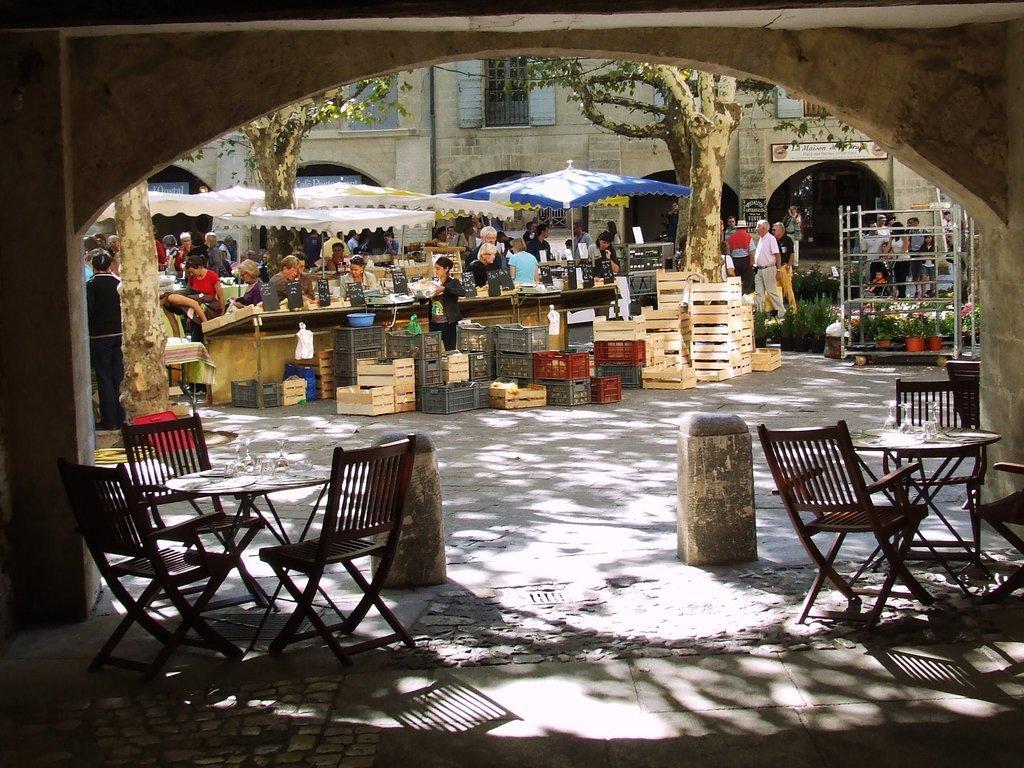In one or two sentences, can you explain what this image depicts? In the foreground of this image, there are chairs, tables on the ground. We can also see bollards and an arch at the top. In the background, there are baskets, few people standing, umbrellas, trees and also we can see the walls, windows and arches of a building. 